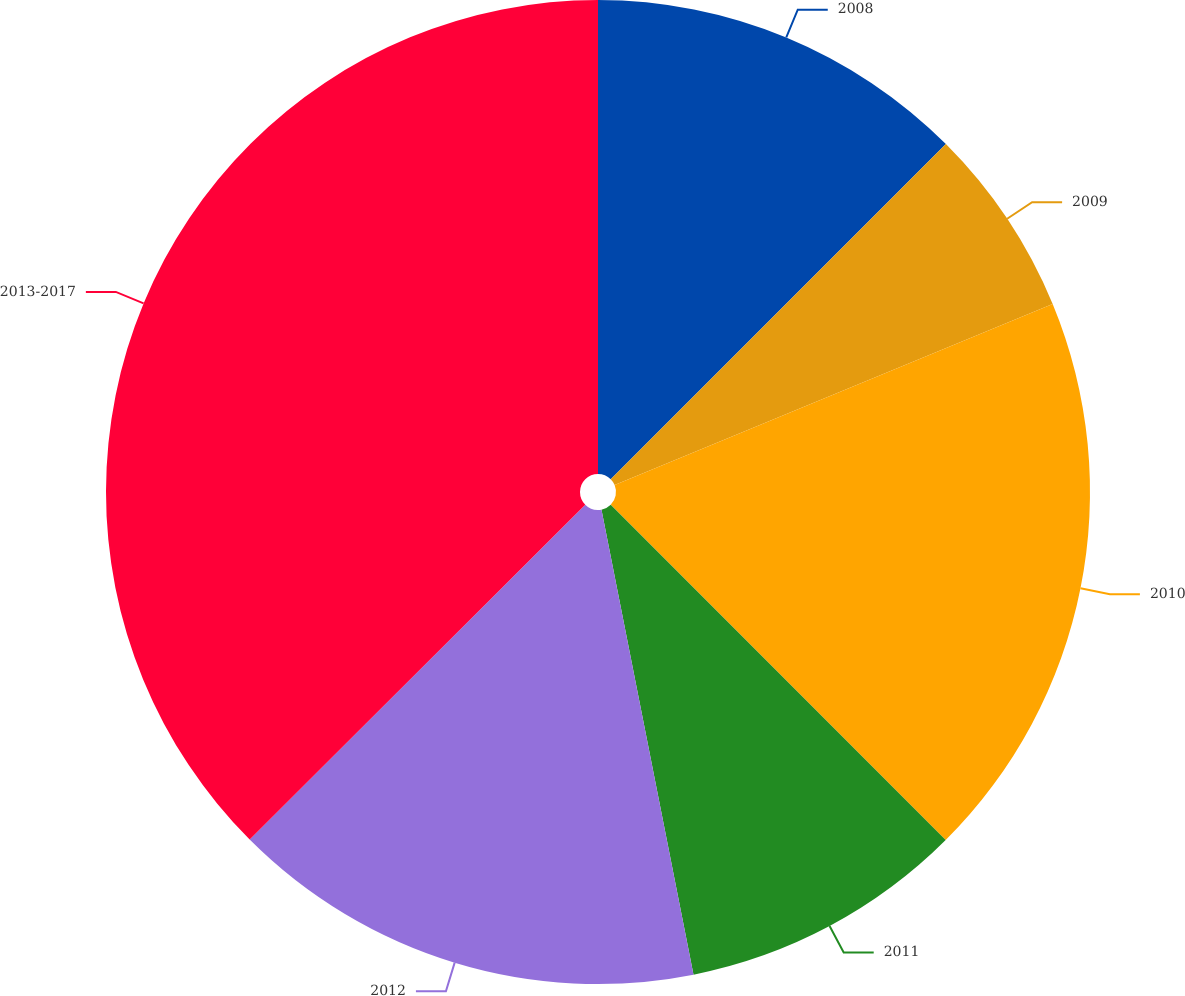Convert chart. <chart><loc_0><loc_0><loc_500><loc_500><pie_chart><fcel>2008<fcel>2009<fcel>2010<fcel>2011<fcel>2012<fcel>2013-2017<nl><fcel>12.5%<fcel>6.26%<fcel>18.75%<fcel>9.38%<fcel>15.63%<fcel>37.48%<nl></chart> 